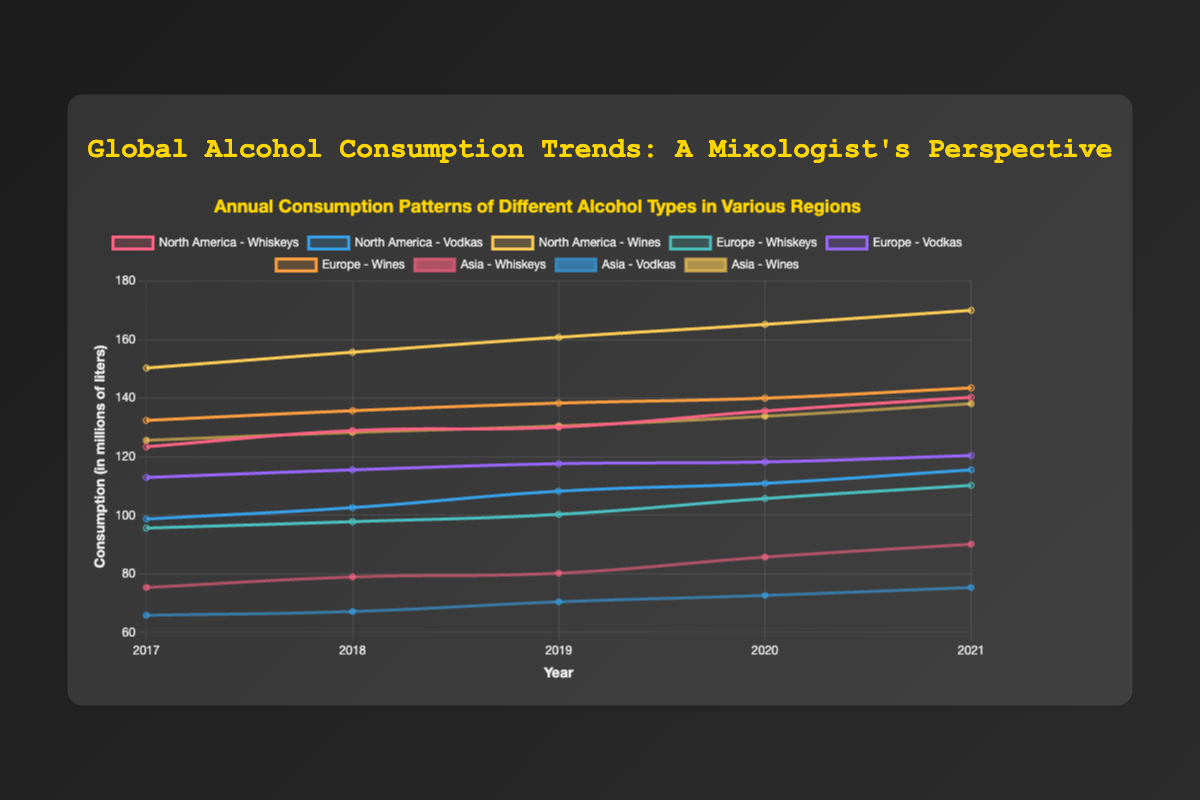Which region had the highest whiskey consumption in 2021? Look at the whiskey consumption data for 2021 and compare across regions. North America had 140.3, Europe had 110.2, and Asia had 90.1. Therefore, North America had the highest.
Answer: North America Which alcohol type showed the highest growth in Europe from 2017 to 2021? Check the consumption numbers for each alcohol type in Europe in 2017 and 2021, then calculate the growth by subtracting 2017 from 2021 values. Whiskeys increased from 95.6 to 110.2 (14.6), Vodkas from 112.9 to 120.4 (7.5), Wines from 132.4 to 143.5 (11.1). The highest growth is in Whiskeys (14.6).
Answer: Whiskeys Which type of alcohol consumption was consistently higher in North America than in Europe throughout the years? Compare the consumption values of Whiskeys, Vodkas, and Wines for North America and Europe from 2017 to 2021 for each year. Whiskeys and Wines in North America are always higher, but Vodkas occasionally have lower values. Hence, Wines (always) and Whiskeys (most of the time).
Answer: Wines and Whiskeys Did any region show a decrease in alcohol consumption between any two consecutive years for any alcohol type? Check the year-to-year consumption values for each region and alcohol type. Look for any drops between consecutive years. All regions and types show an increase each year.
Answer: No By how much did vodka consumption in Asia increase from 2017 to 2021? Subtract the 2017 vodka consumption value from the 2021 value for Asia. 2021 value is 75.3 and 2017 value is 65.8. The increase is 75.3 - 65.8 = 9.5.
Answer: 9.5 Which alcohol type and region combination had the smallest consumption in 2017? Look up the consumption values for each combination in 2017. Whiskeys in Asia had the smallest value of 75.3.
Answer: Asia - Whiskeys Did wine consumption in any of the regions exceed 160 million liters by 2021? Check the wine consumption values for the regions in 2021. North America and Europe do not exceed 160 million liters, but Asia does with 138.1 million liters.
Answer: No What is the difference in the whiskey consumption between North America and Asia in 2019? Find the 2019 whiskey consumption values for North America (130.1) and Asia (80.2), then subtract the Asian value from the North American value. 130.1 - 80.2 = 49.9.
Answer: 49.9 